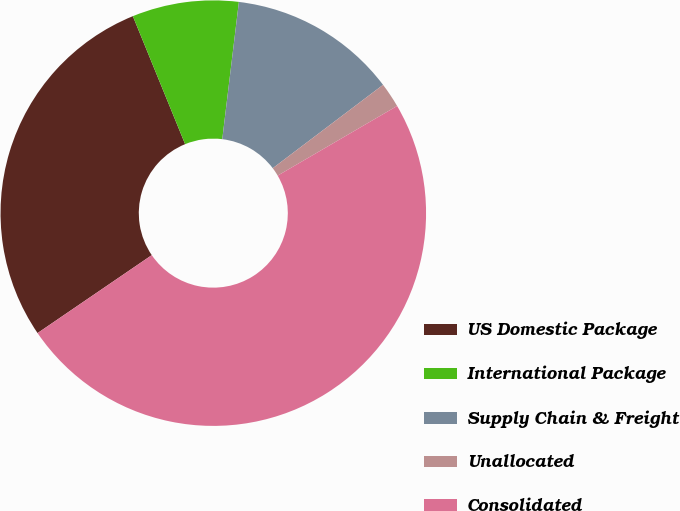Convert chart. <chart><loc_0><loc_0><loc_500><loc_500><pie_chart><fcel>US Domestic Package<fcel>International Package<fcel>Supply Chain & Freight<fcel>Unallocated<fcel>Consolidated<nl><fcel>28.36%<fcel>8.09%<fcel>12.78%<fcel>1.9%<fcel>48.87%<nl></chart> 